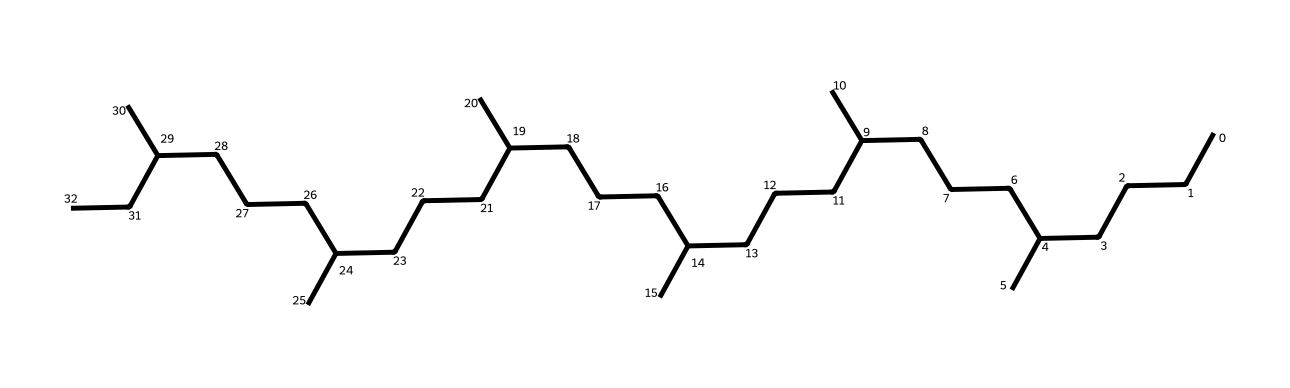What is the name of this chemical? This chemical is known as squalane, which is a saturated hydrocarbon derived from squalene, a natural organic compound. The structure adheres to the characteristics typical of alkanes, confirming its classification as squalane.
Answer: squalane How many carbon atoms are in this structure? By analyzing the SMILES representation, each "C" corresponds to a carbon atom. Counting the unique carbon symbols results in a total of 30 carbon atoms in the structure.
Answer: 30 What type of bonds are present in squalane? The SMILES notation indicates that it is a saturated hydrocarbon, which means it contains only single covalent bonds between the carbon atoms. Therefore, the bonds in squalane are only single bonds.
Answer: single bonds Is squalane polar or non-polar? Since squalane is comprised solely of carbon and hydrogen atoms, it has a balanced distribution of electrical charges and lacks significant polarity. This results in a non-polar character for the molecule.
Answer: non-polar What role does the long carbon chain play in the properties of squalane? The long carbon chain contributes to squalane’s excellent emollient properties, making it effective for skin hydration. This structure allows for better occlusion on the skin surface, enhancing moisture retention.
Answer: emollient properties Which functional group is absent in squalane compared to its precursor? Squalane lacks the double bonds that are present in squalene, its precursor. The absence of these double bonds implies that it is fully saturated, leading to greater stability and improved moisturizing properties.
Answer: double bonds Why is squalane considered a renewable resource? Squalane is derived from plant sources, such as olives, and is obtained through renewable extraction processes. This positions it as a sustainable ingredient compared to synthetic alternatives, supporting environmentally friendly practices in cosmetics.
Answer: renewable resource 